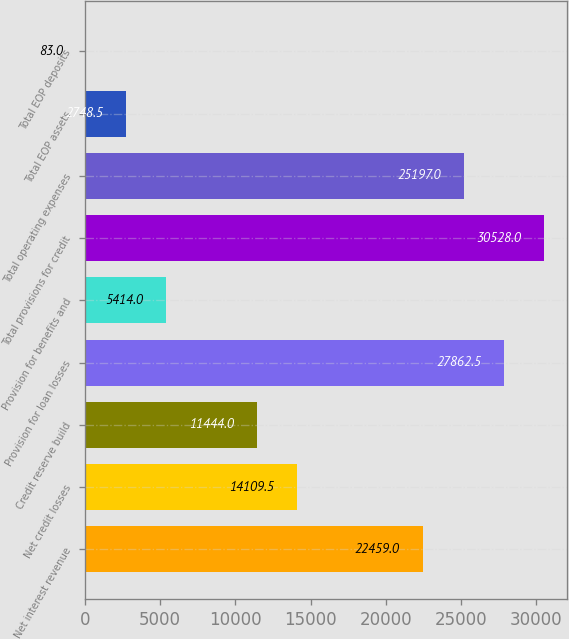Convert chart to OTSL. <chart><loc_0><loc_0><loc_500><loc_500><bar_chart><fcel>Net interest revenue<fcel>Net credit losses<fcel>Credit reserve build<fcel>Provision for loan losses<fcel>Provision for benefits and<fcel>Total provisions for credit<fcel>Total operating expenses<fcel>Total EOP assets<fcel>Total EOP deposits<nl><fcel>22459<fcel>14109.5<fcel>11444<fcel>27862.5<fcel>5414<fcel>30528<fcel>25197<fcel>2748.5<fcel>83<nl></chart> 